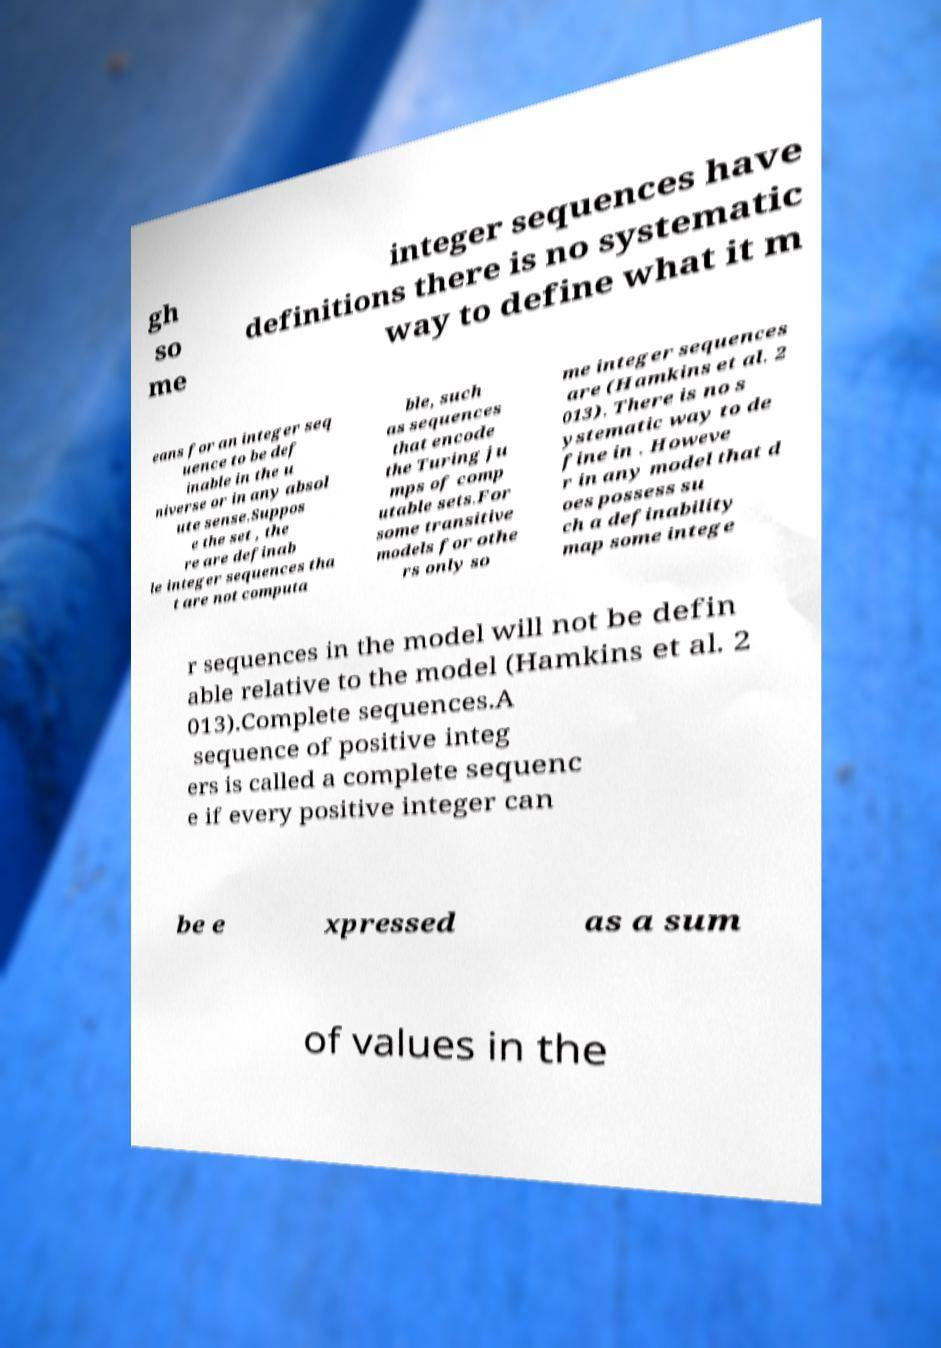What messages or text are displayed in this image? I need them in a readable, typed format. gh so me integer sequences have definitions there is no systematic way to define what it m eans for an integer seq uence to be def inable in the u niverse or in any absol ute sense.Suppos e the set , the re are definab le integer sequences tha t are not computa ble, such as sequences that encode the Turing ju mps of comp utable sets.For some transitive models for othe rs only so me integer sequences are (Hamkins et al. 2 013). There is no s ystematic way to de fine in . Howeve r in any model that d oes possess su ch a definability map some intege r sequences in the model will not be defin able relative to the model (Hamkins et al. 2 013).Complete sequences.A sequence of positive integ ers is called a complete sequenc e if every positive integer can be e xpressed as a sum of values in the 